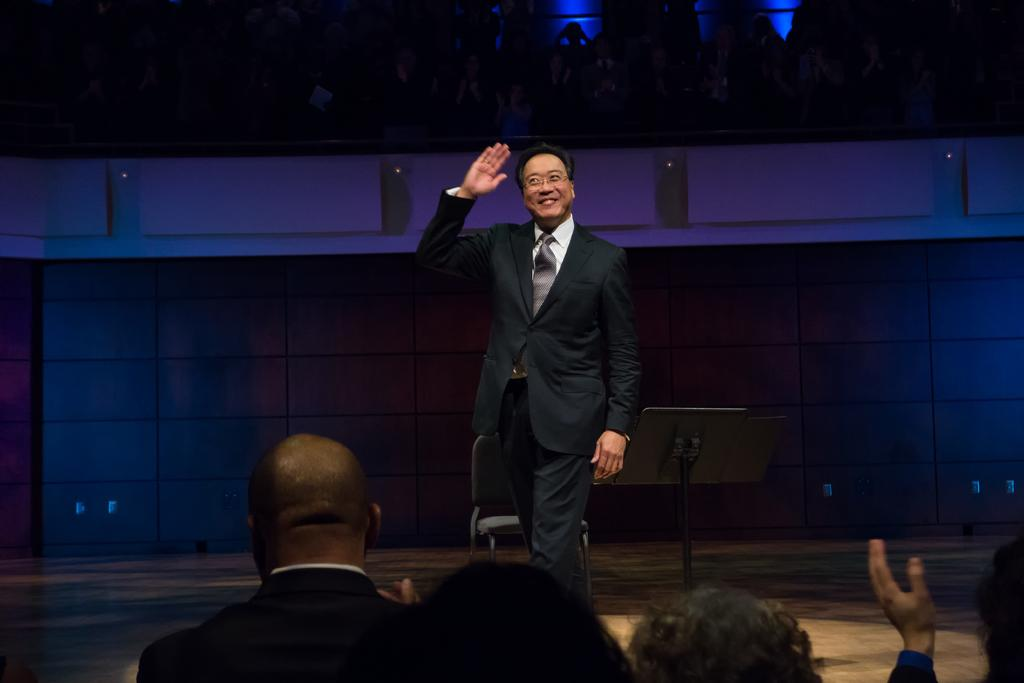What is the main subject in the image? There is a person standing in the image. What is located behind the person? There is a chair, a stand, and a wall behind the person. Can you describe the group of persons in the image? There is a group of persons at the top of the image, and there are few persons at the bottom of the image. What type of rail is present in the image? There is no rail present in the image. What rhythm is the person following while standing in the image? The person is not following any rhythm in the image; they are simply standing. 